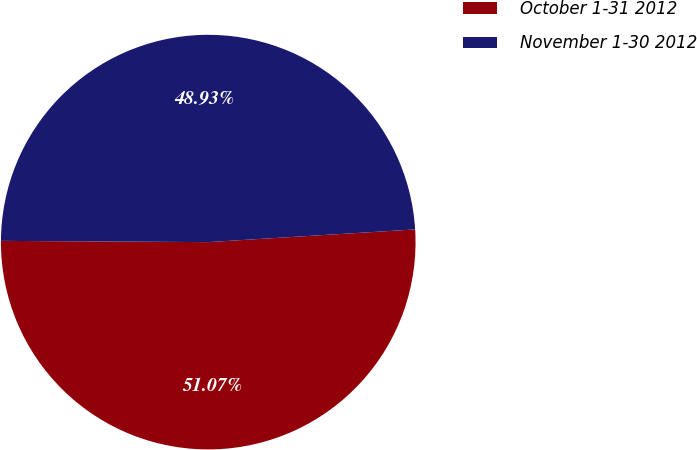<chart> <loc_0><loc_0><loc_500><loc_500><pie_chart><fcel>October 1-31 2012<fcel>November 1-30 2012<nl><fcel>51.07%<fcel>48.93%<nl></chart> 